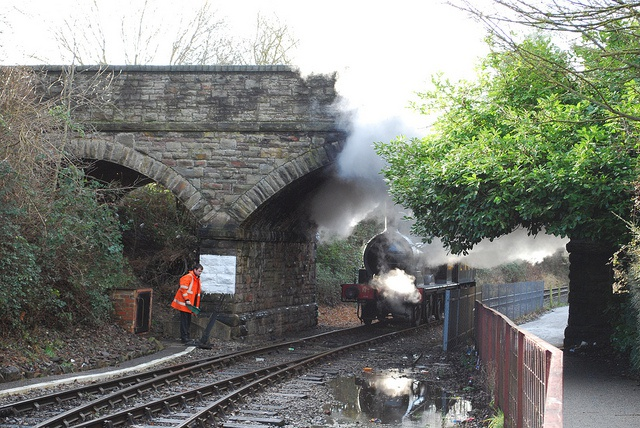Describe the objects in this image and their specific colors. I can see train in white, black, gray, and darkgray tones and people in white, black, red, and brown tones in this image. 